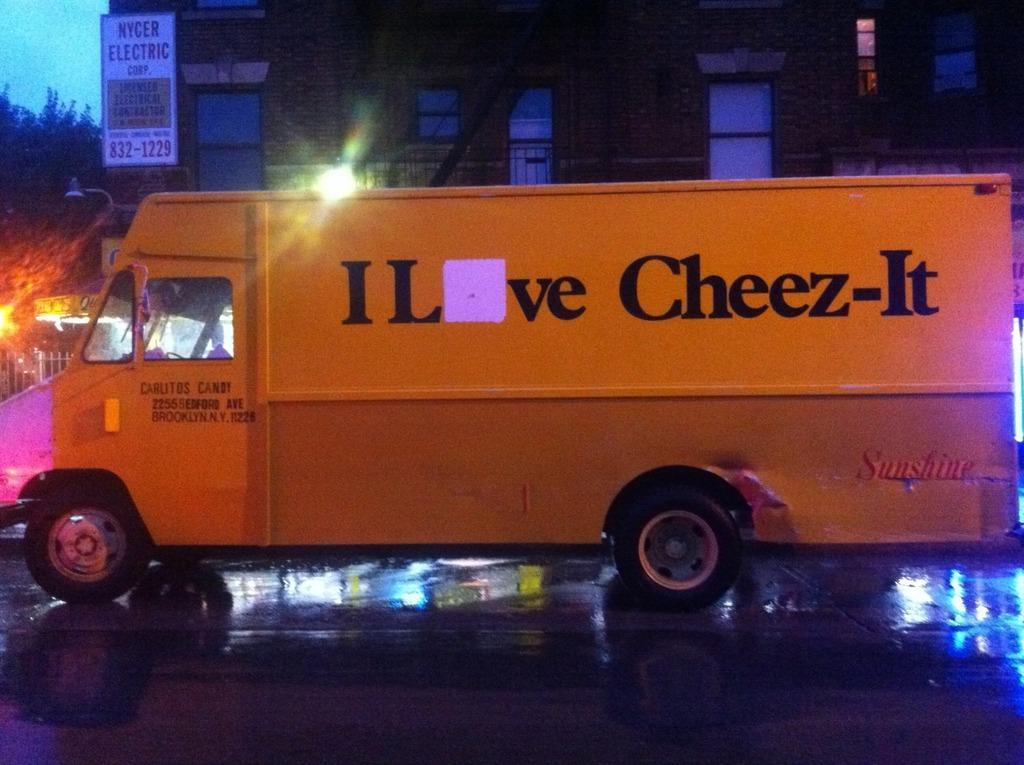Can you describe this image briefly? This image is taken outdoors. At the bottom of the image there is a road. In the background there is a building. There are a few trees. There is a fence. There is a light. There is a board with a text on it. In the middle of the image a truck is parked on the road. 